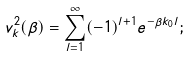<formula> <loc_0><loc_0><loc_500><loc_500>v _ { k } ^ { 2 } ( \beta ) = \sum _ { l = 1 } ^ { \infty } ( - 1 ) ^ { l + 1 } e ^ { - \beta k _ { 0 } l } ;</formula> 